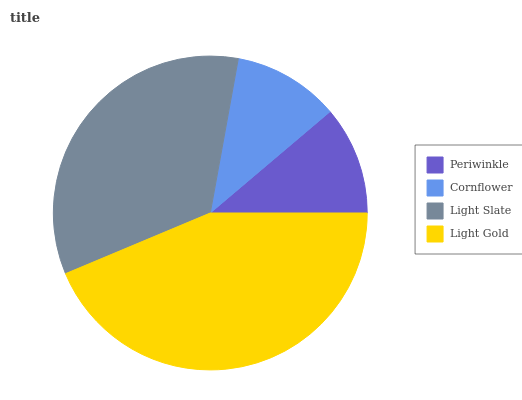Is Cornflower the minimum?
Answer yes or no. Yes. Is Light Gold the maximum?
Answer yes or no. Yes. Is Light Slate the minimum?
Answer yes or no. No. Is Light Slate the maximum?
Answer yes or no. No. Is Light Slate greater than Cornflower?
Answer yes or no. Yes. Is Cornflower less than Light Slate?
Answer yes or no. Yes. Is Cornflower greater than Light Slate?
Answer yes or no. No. Is Light Slate less than Cornflower?
Answer yes or no. No. Is Light Slate the high median?
Answer yes or no. Yes. Is Periwinkle the low median?
Answer yes or no. Yes. Is Periwinkle the high median?
Answer yes or no. No. Is Light Slate the low median?
Answer yes or no. No. 